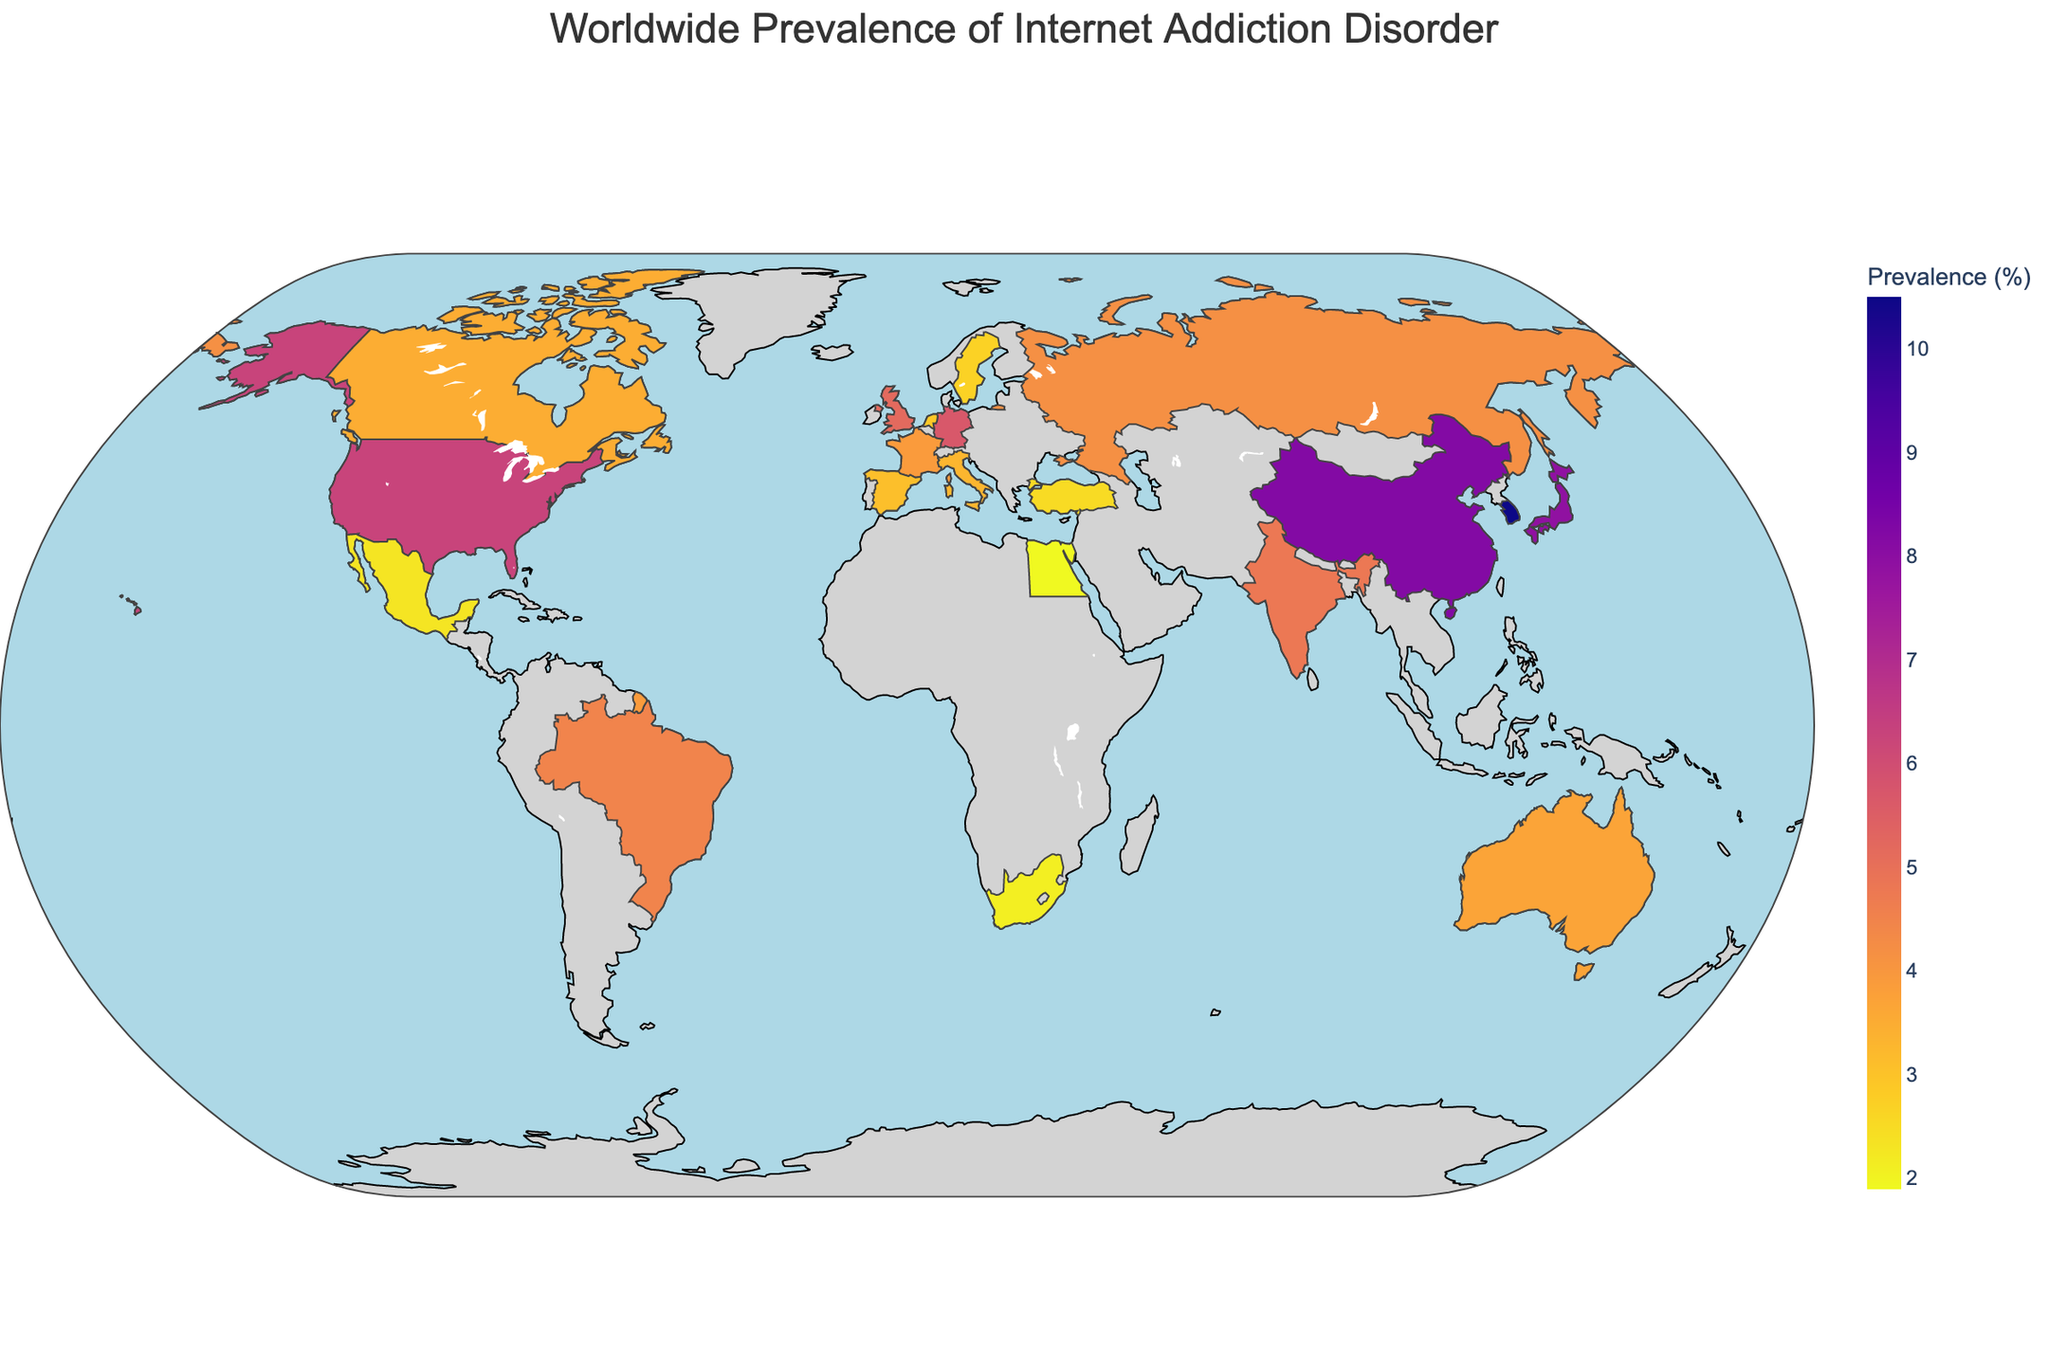what is the title of the figure? The title is usually found at the top of the figure. In this case, it is clearly indicated.
Answer: Worldwide Prevalence of Internet Addiction Disorder Which three countries have the highest prevalence of internet addiction disorder? By looking at the color scale and the intensity of the color on the map, we can identify the top three countries.
Answer: South Korea, China, Japan Which three countries have the lowest prevalence of internet addiction disorder? Similarly, by looking at the lighter colors on the map and referring to the color scale, the countries with the lowest prevalence can be identified.
Answer: Egypt, South Africa, Mexico What is the prevalence percentage of internet addiction in the United States? Locate the United States on the map, and the prevalence percentage is shown when you hover over the country.
Answer: 6.3% How does the prevalence of internet addiction in India compare to that in the United Kingdom? Locate both India and the United Kingdom on the map, and compare their prevalence percentages. India has a prevalence of 4.8% while the United Kingdom has 5.2%.
Answer: India's prevalence is lower than the United Kingdom's Calculate the average prevalence percentage of internet addiction in South Africa, Egypt, and Turkey. Add the prevalence percentages of these three countries and divide by three: (2.1 + 1.9 + 2.5) / 3 = 6.5 / 3.
Answer: 2.17% Which region, Asia or Europe, shows higher internet addiction prevalence in general? Identify the countries in each region and compare the prevalence percentages. Note that Asia has countries like South Korea (10.5%) and China (8.2%), while Europe includes the United Kingdom (5.2%) and Germany (5.7%).
Answer: Asia What's the difference in internet addiction prevalence between Canada and Australia? Subtract Australia's prevalence percentage from Canada's: 3.5% - 3.7%.
Answer: -0.2% Identify any outliers regarding the prevalence of internet addiction compared to neighboring countries. Highlight countries with significantly higher or lower prevalence compared to their neighbors, like South Korea being much higher than Japan and China.
Answer: South Korea How does the prevalence of internet addiction in Brazil compare to that in Russia? Locate both Brazil and Russia on the map, and compare their prevalence percentages directly.
Answer: Brazil's prevalence (4.5%) is higher than Russia's (4.2%) 